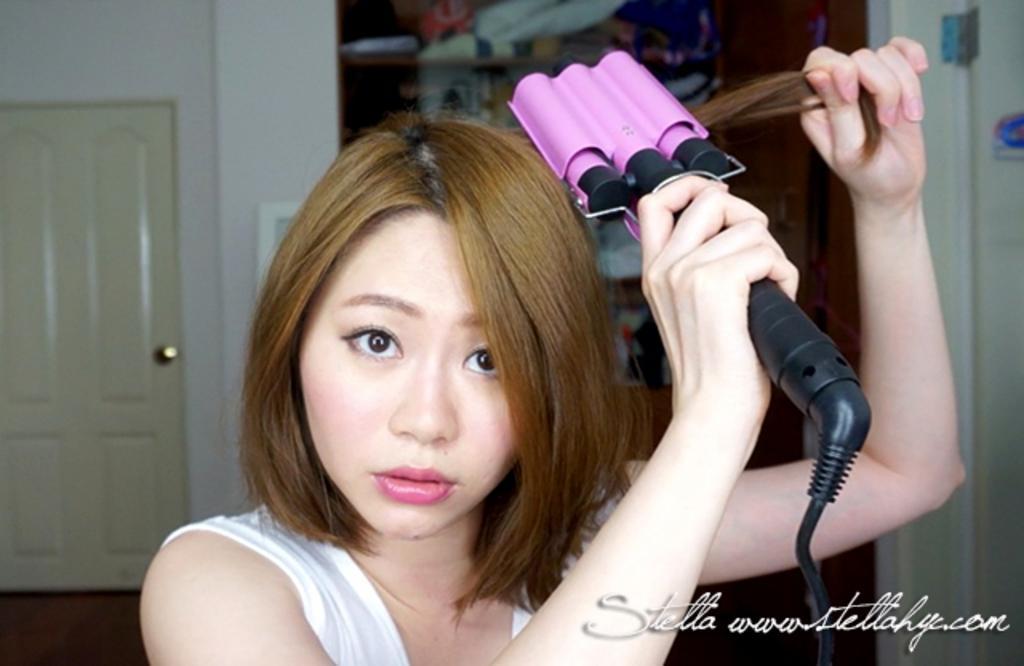Please provide a concise description of this image. In this image there is a woman. She is holding hairs and a hair curler in her hand. Behind her there is a wall. To the left there is a door to the wall. At the bottom there is text on the image. 